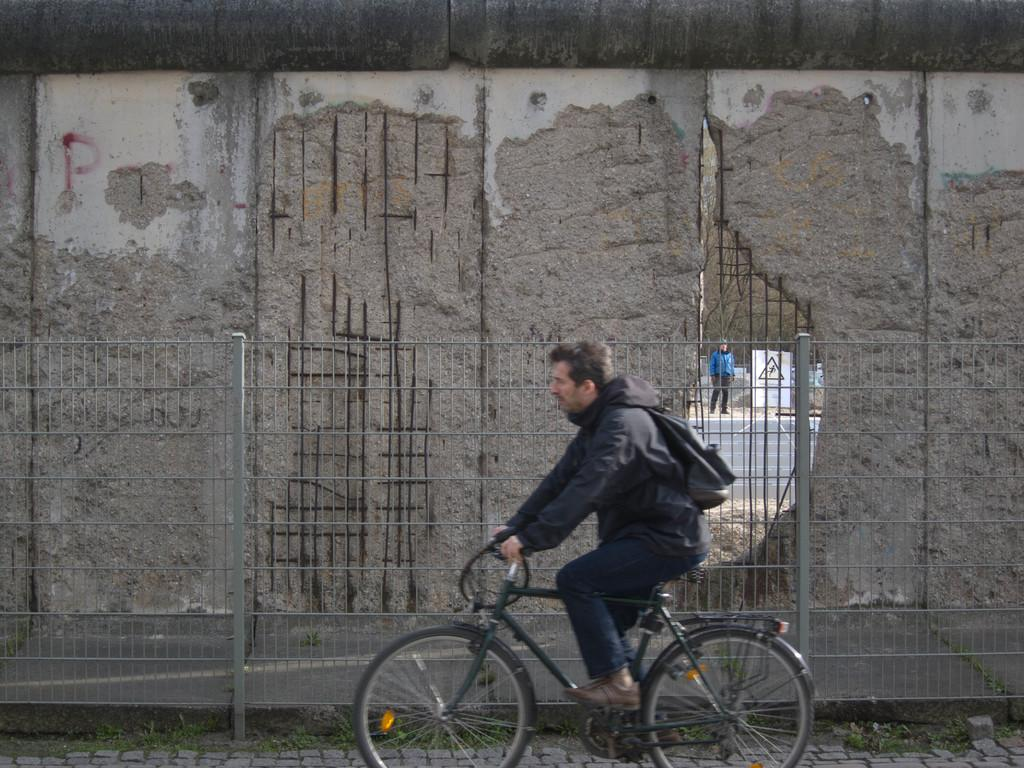What is the main subject of the image? There is a man riding a bicycle in the image. What can be seen in the background of the image? There is a fence and a wall in the background of the image. Are there any other people visible in the image? Yes, there is a man standing in the background of the image. What type of marble is being mined in the background of the image? There is no marble or mining activity present in the image. What kind of music is the band playing in the background of the image? There is no band or music present in the image. 